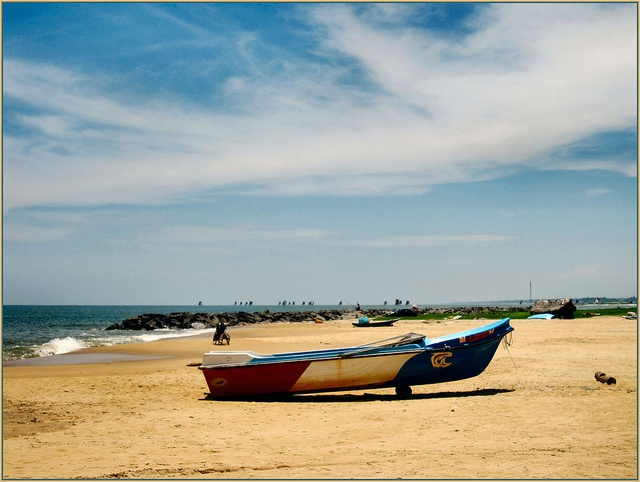Describe the objects in this image and their specific colors. I can see boat in tan, black, maroon, and olive tones, boat in tan, black, teal, and gray tones, people in tan, black, and gray tones, people in tan, black, brown, maroon, and gray tones, and people in tan, teal, blue, gray, and darkgray tones in this image. 